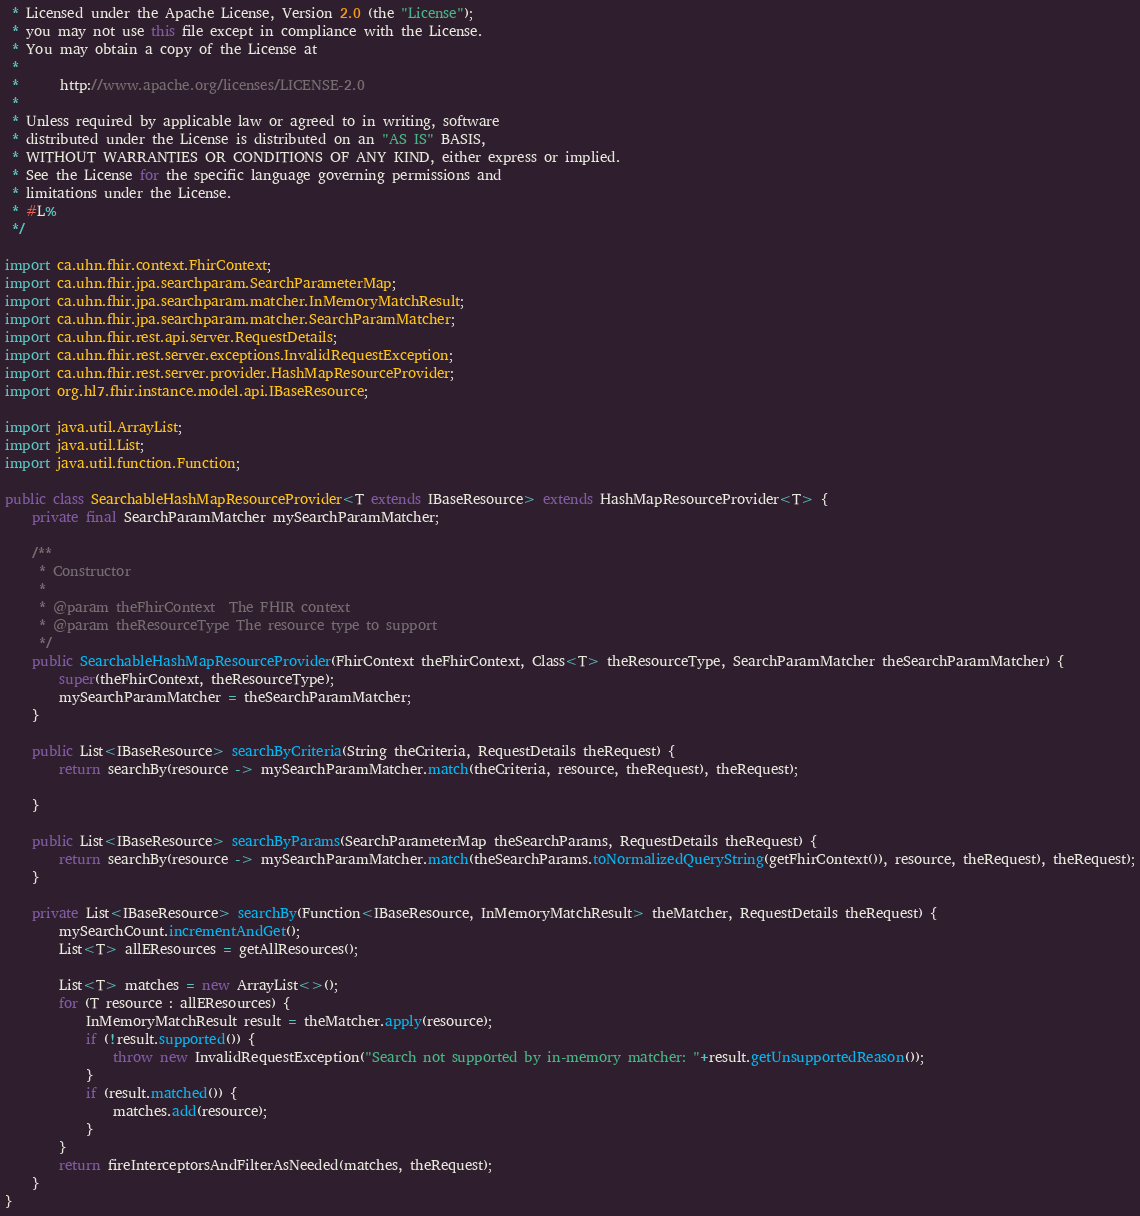<code> <loc_0><loc_0><loc_500><loc_500><_Java_> * Licensed under the Apache License, Version 2.0 (the "License");
 * you may not use this file except in compliance with the License.
 * You may obtain a copy of the License at
 *
 *      http://www.apache.org/licenses/LICENSE-2.0
 *
 * Unless required by applicable law or agreed to in writing, software
 * distributed under the License is distributed on an "AS IS" BASIS,
 * WITHOUT WARRANTIES OR CONDITIONS OF ANY KIND, either express or implied.
 * See the License for the specific language governing permissions and
 * limitations under the License.
 * #L%
 */

import ca.uhn.fhir.context.FhirContext;
import ca.uhn.fhir.jpa.searchparam.SearchParameterMap;
import ca.uhn.fhir.jpa.searchparam.matcher.InMemoryMatchResult;
import ca.uhn.fhir.jpa.searchparam.matcher.SearchParamMatcher;
import ca.uhn.fhir.rest.api.server.RequestDetails;
import ca.uhn.fhir.rest.server.exceptions.InvalidRequestException;
import ca.uhn.fhir.rest.server.provider.HashMapResourceProvider;
import org.hl7.fhir.instance.model.api.IBaseResource;

import java.util.ArrayList;
import java.util.List;
import java.util.function.Function;

public class SearchableHashMapResourceProvider<T extends IBaseResource> extends HashMapResourceProvider<T> {
	private final SearchParamMatcher mySearchParamMatcher;

	/**
	 * Constructor
	 *
	 * @param theFhirContext  The FHIR context
	 * @param theResourceType The resource type to support
	 */
	public SearchableHashMapResourceProvider(FhirContext theFhirContext, Class<T> theResourceType, SearchParamMatcher theSearchParamMatcher) {
		super(theFhirContext, theResourceType);
		mySearchParamMatcher = theSearchParamMatcher;
	}

	public List<IBaseResource> searchByCriteria(String theCriteria, RequestDetails theRequest) {
		return searchBy(resource -> mySearchParamMatcher.match(theCriteria, resource, theRequest), theRequest);

	}

	public List<IBaseResource> searchByParams(SearchParameterMap theSearchParams, RequestDetails theRequest) {
		return searchBy(resource -> mySearchParamMatcher.match(theSearchParams.toNormalizedQueryString(getFhirContext()), resource, theRequest), theRequest);
	}

	private List<IBaseResource> searchBy(Function<IBaseResource, InMemoryMatchResult> theMatcher, RequestDetails theRequest) {
		mySearchCount.incrementAndGet();
		List<T> allEResources = getAllResources();

		List<T> matches = new ArrayList<>();
		for (T resource : allEResources) {
			InMemoryMatchResult result = theMatcher.apply(resource);
			if (!result.supported()) {
				throw new InvalidRequestException("Search not supported by in-memory matcher: "+result.getUnsupportedReason());
			}
			if (result.matched()) {
				matches.add(resource);
			}
		}
		return fireInterceptorsAndFilterAsNeeded(matches, theRequest);
	}
}
</code> 